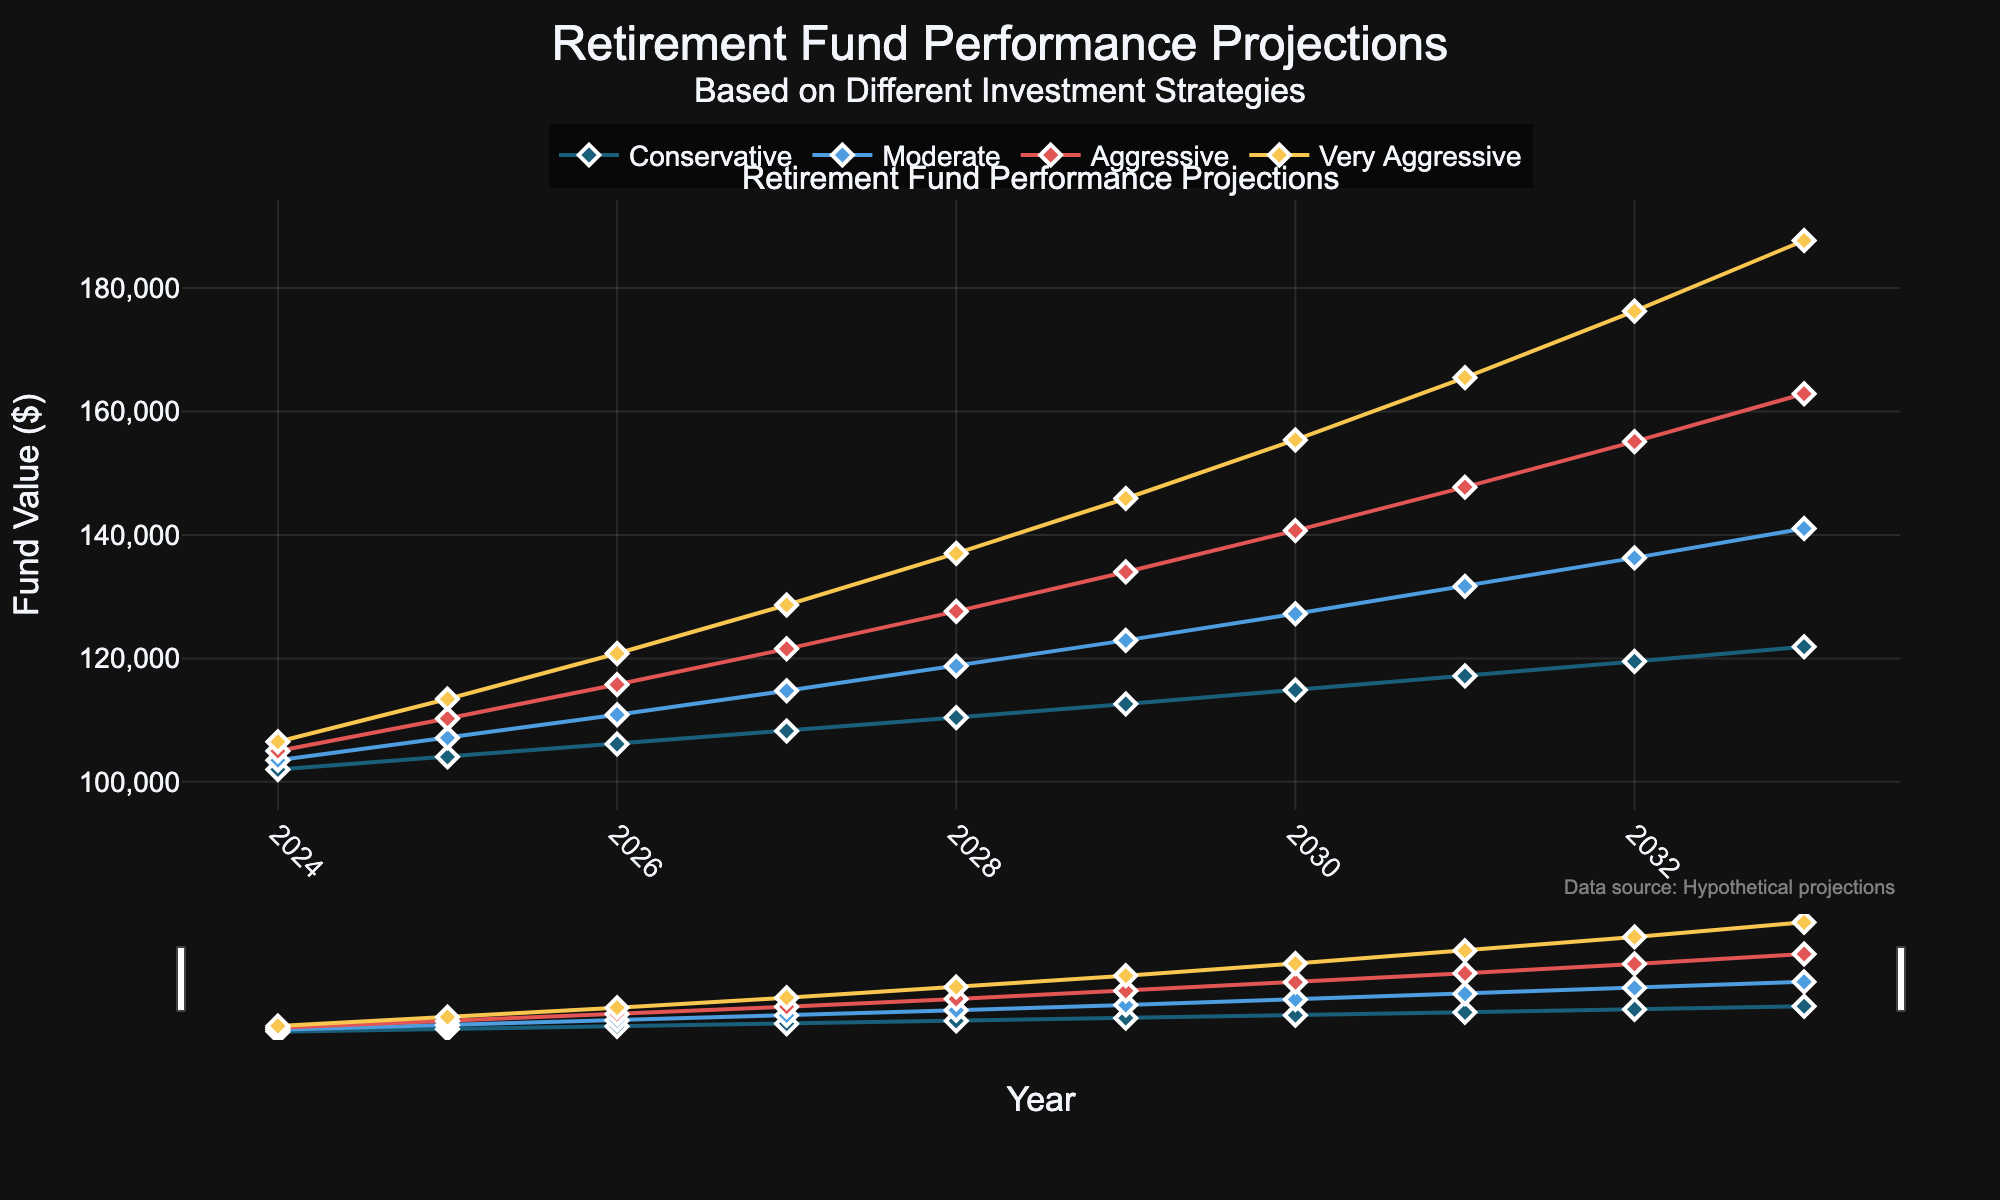What is the title of the figure? The title is mentioned at the top of the figure. It reads "Retirement Fund Performance Projections Based on Different Investment Strategies". The subtitle helps to provide additional context about the contents.
Answer: Retirement Fund Performance Projections Based on Different Investment Strategies What is the value of the Conservative strategy in 2030? Locate the year 2030 on the x-axis and then find the corresponding value for the Conservative strategy from the y-axis or the data points. According to the data provided, it is 114869 dollars.
Answer: 114869 How many years of projection data are shown in the figure? The x-axis shows years from 2024 to 2033. Count each year incrementally to find the total number of years displayed.
Answer: 10 Which investment strategy has the highest projected value in 2033? Look at the y-axis values for the strategies in the year 2033. The Very Aggressive strategy has the highest value, which is 187715 dollars.
Answer: Very Aggressive What is the difference in the projected fund value between the Aggressive and Conservative strategies in 2026? Locate the year 2026 on the x-axis, then find the values for both Aggressive and Conservative strategies. The values are 115763 and 106121 dollars respectively. Subtract the Conservative value from the Aggressive value to find the difference. 115763 - 106121 = 9642 dollars.
Answer: 9642 What is the average annual growth rate for the Moderate strategy from 2024 to 2025? Find the Moderate strategy values for 2024 and 2025, which are 103500 and 107122 dollars respectively. Calculate the growth rate: ((107122 - 103500) / 103500) * 100. The growth rate is approximately 3.50%.
Answer: 3.50% In which year does the Very Aggressive strategy first exceed 150000 dollars? Look for the first instance in the Very Aggressive strategy values where it exceeds 150000 dollars. This occurs in 2029 with a value of 145915 dollars. So, it first exceeds this amount in 2030.
Answer: 2030 By how much does the Very Aggressive strategy outperform the Conservative strategy in 2028? Find the values for both strategies in the year 2028. The Conservative value is 110408 dollars, and the Very Aggressive value is 137009 dollars. Subtract the Conservative value from the Very Aggressive value to determine the difference. 137009 - 110408 = 26601 dollars.
Answer: 26601 Which year shows the smallest difference in projected fund value between the Moderate and Aggressive strategies? Calculate the value differences for each year between the Moderate and Aggressive strategies, then identify the smallest one. For example, in 2024 the difference is 1500; in 2025 it is 3128; in 2026 it is 4891; etc. The smallest difference occurs in 2033 with a difference of 66289 - 141059 - 162890 = 17831 dollars.
Answer: 2024 